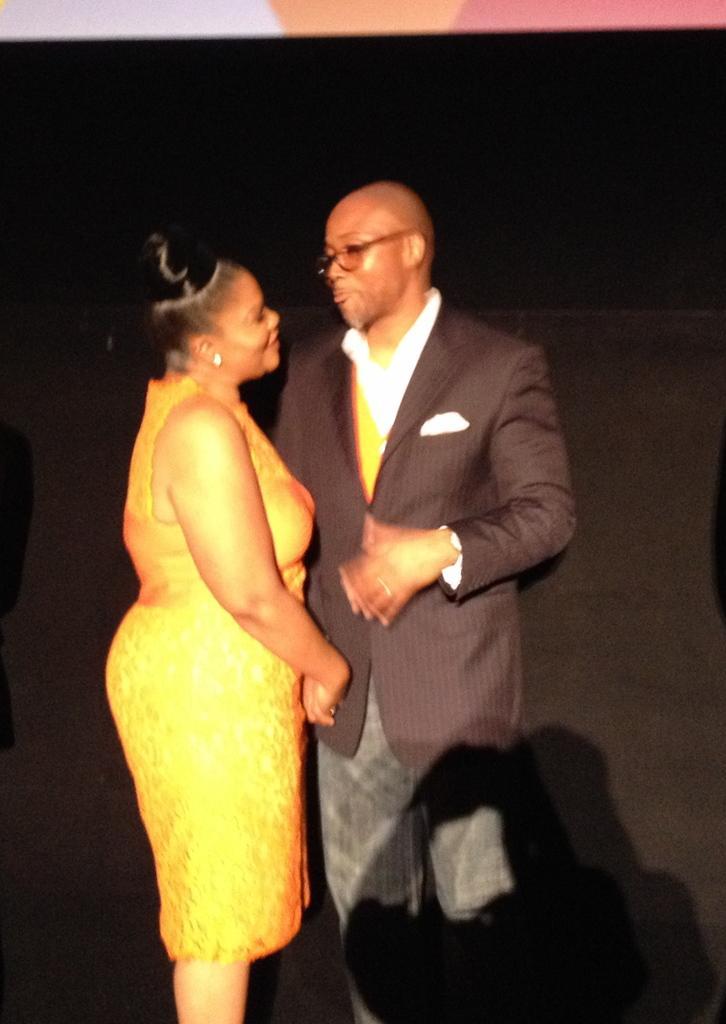In one or two sentences, can you explain what this image depicts? In this picture we can see a man, woman standing and shaking their hands. 